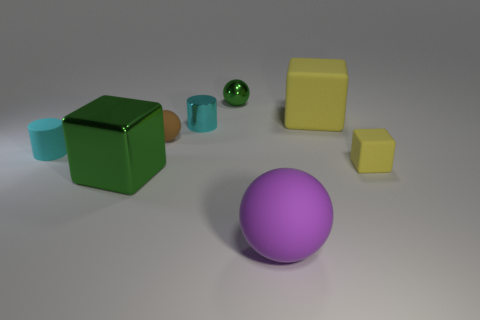Are the large purple object and the large yellow thing made of the same material?
Provide a succinct answer. Yes. How many balls are tiny cyan things or matte objects?
Ensure brevity in your answer.  2. There is a large object behind the brown rubber ball; what is its color?
Make the answer very short. Yellow. What number of matte things are either big balls or small blue spheres?
Give a very brief answer. 1. There is a cyan object to the right of the block that is to the left of the large sphere; what is its material?
Offer a very short reply. Metal. There is a thing that is the same color as the tiny matte cylinder; what is it made of?
Provide a succinct answer. Metal. What is the color of the large metallic thing?
Keep it short and to the point. Green. Is there a yellow object behind the small cyan cylinder that is to the right of the brown rubber ball?
Provide a short and direct response. Yes. What is the big purple ball made of?
Offer a terse response. Rubber. Is the tiny object that is to the right of the large purple rubber thing made of the same material as the tiny cyan cylinder to the left of the large green cube?
Offer a very short reply. Yes. 